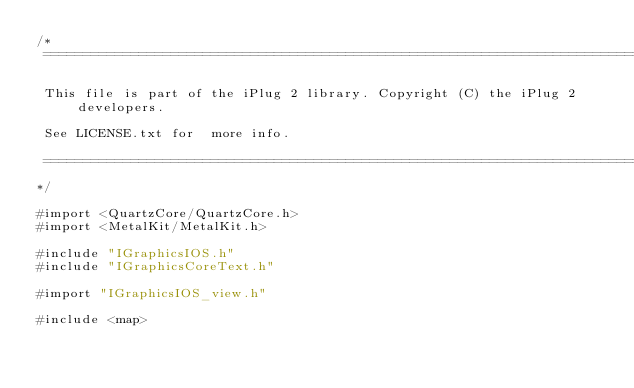Convert code to text. <code><loc_0><loc_0><loc_500><loc_500><_ObjectiveC_>/*
 ==============================================================================

 This file is part of the iPlug 2 library. Copyright (C) the iPlug 2 developers.

 See LICENSE.txt for  more info.

 ==============================================================================
*/

#import <QuartzCore/QuartzCore.h>
#import <MetalKit/MetalKit.h>

#include "IGraphicsIOS.h"
#include "IGraphicsCoreText.h"

#import "IGraphicsIOS_view.h"

#include <map></code> 